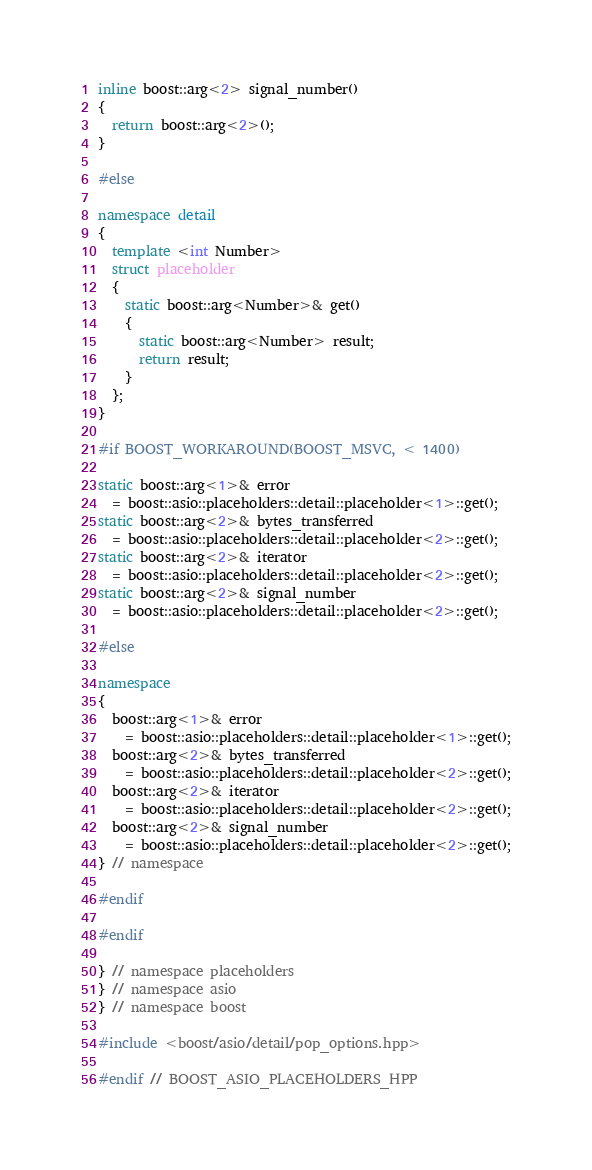Convert code to text. <code><loc_0><loc_0><loc_500><loc_500><_C++_>
inline boost::arg<2> signal_number()
{
  return boost::arg<2>();
}

#else

namespace detail
{
  template <int Number>
  struct placeholder
  {
    static boost::arg<Number>& get()
    {
      static boost::arg<Number> result;
      return result;
    }
  };
}

#if BOOST_WORKAROUND(BOOST_MSVC, < 1400)

static boost::arg<1>& error
  = boost::asio::placeholders::detail::placeholder<1>::get();
static boost::arg<2>& bytes_transferred
  = boost::asio::placeholders::detail::placeholder<2>::get();
static boost::arg<2>& iterator
  = boost::asio::placeholders::detail::placeholder<2>::get();
static boost::arg<2>& signal_number
  = boost::asio::placeholders::detail::placeholder<2>::get();

#else

namespace
{
  boost::arg<1>& error
    = boost::asio::placeholders::detail::placeholder<1>::get();
  boost::arg<2>& bytes_transferred
    = boost::asio::placeholders::detail::placeholder<2>::get();
  boost::arg<2>& iterator
    = boost::asio::placeholders::detail::placeholder<2>::get();
  boost::arg<2>& signal_number
    = boost::asio::placeholders::detail::placeholder<2>::get();
} // namespace

#endif

#endif

} // namespace placeholders
} // namespace asio
} // namespace boost

#include <boost/asio/detail/pop_options.hpp>

#endif // BOOST_ASIO_PLACEHOLDERS_HPP
</code> 